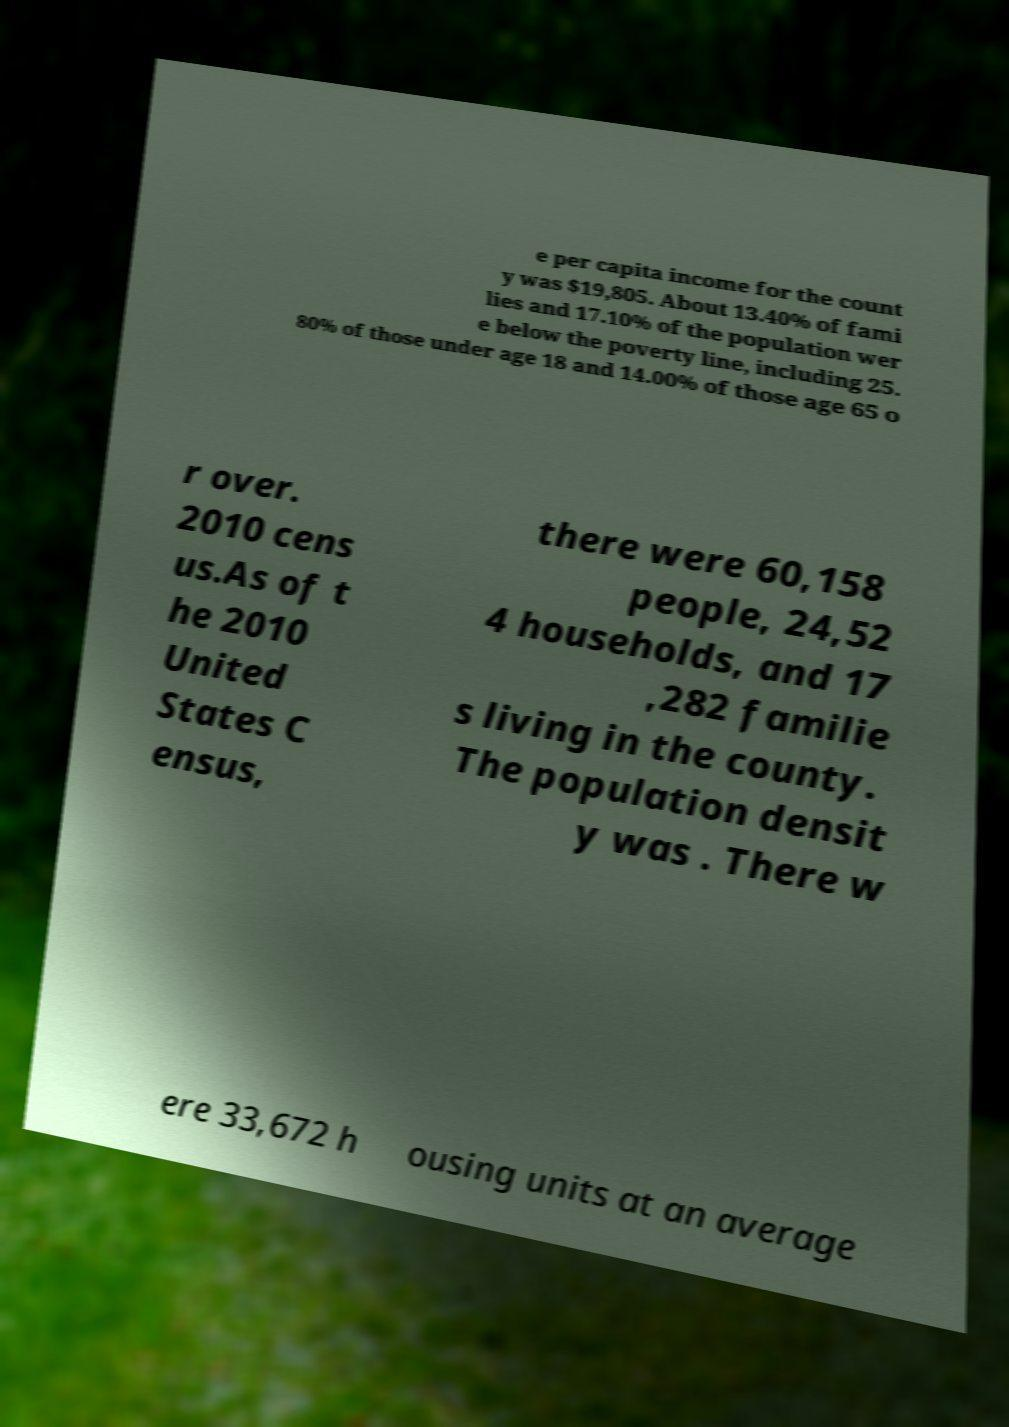For documentation purposes, I need the text within this image transcribed. Could you provide that? e per capita income for the count y was $19,805. About 13.40% of fami lies and 17.10% of the population wer e below the poverty line, including 25. 80% of those under age 18 and 14.00% of those age 65 o r over. 2010 cens us.As of t he 2010 United States C ensus, there were 60,158 people, 24,52 4 households, and 17 ,282 familie s living in the county. The population densit y was . There w ere 33,672 h ousing units at an average 